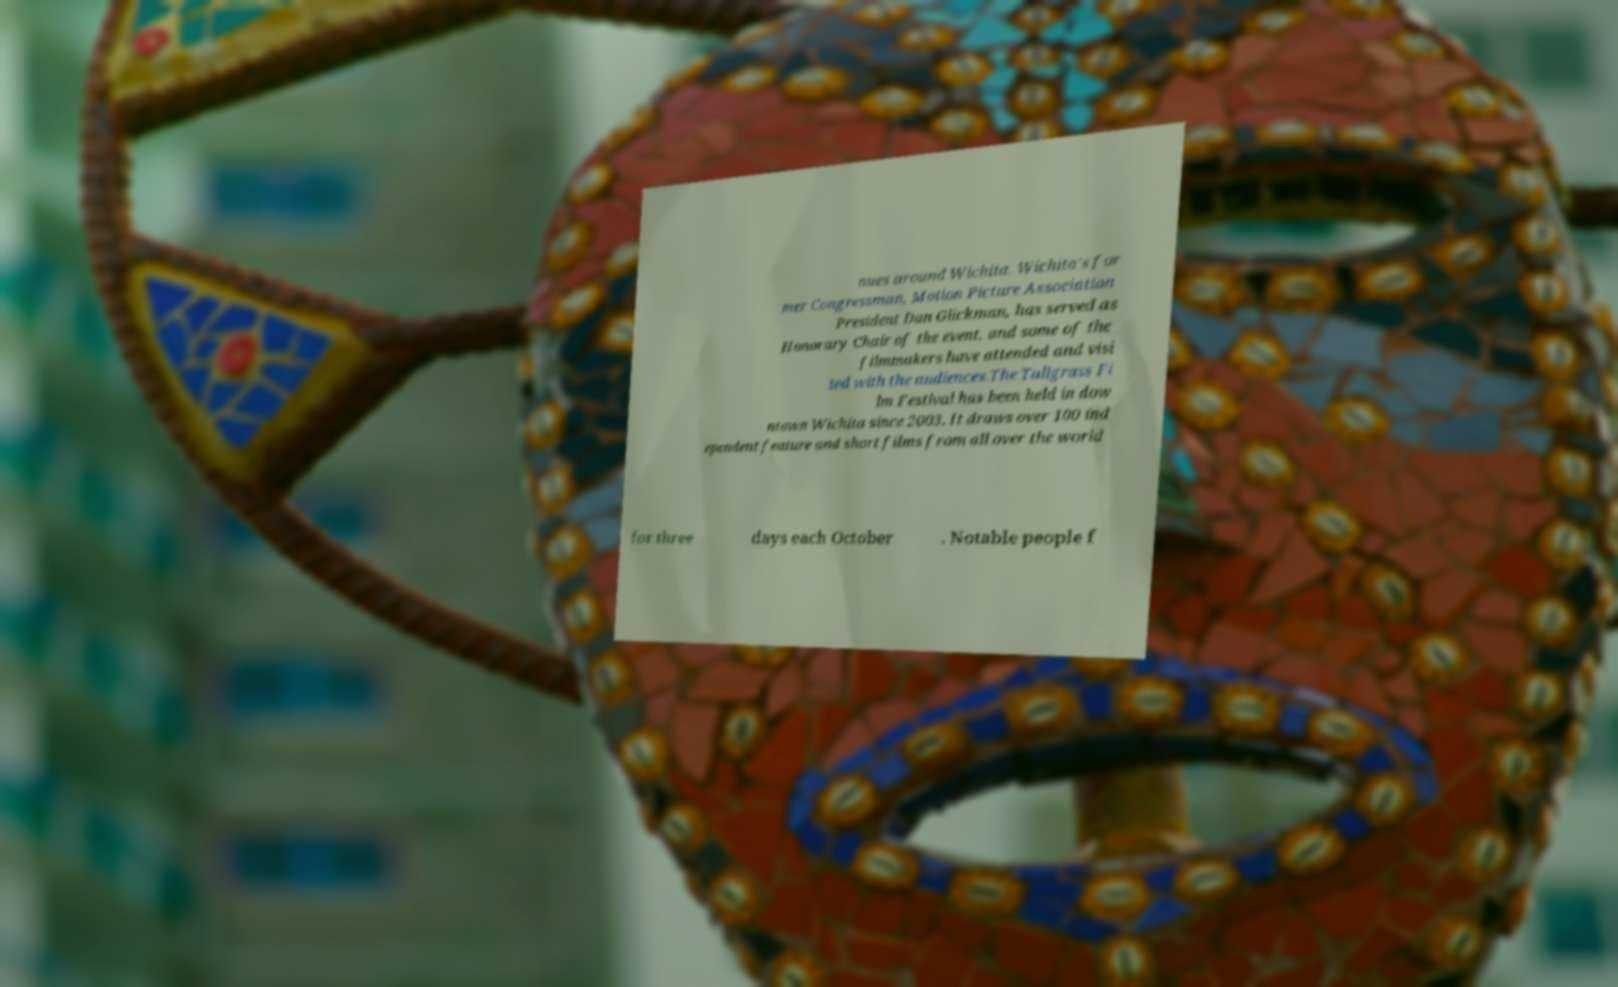Could you assist in decoding the text presented in this image and type it out clearly? nues around Wichita. Wichita's for mer Congressman, Motion Picture Association President Dan Glickman, has served as Honorary Chair of the event, and some of the filmmakers have attended and visi ted with the audiences.The Tallgrass Fi lm Festival has been held in dow ntown Wichita since 2003. It draws over 100 ind ependent feature and short films from all over the world for three days each October . Notable people f 